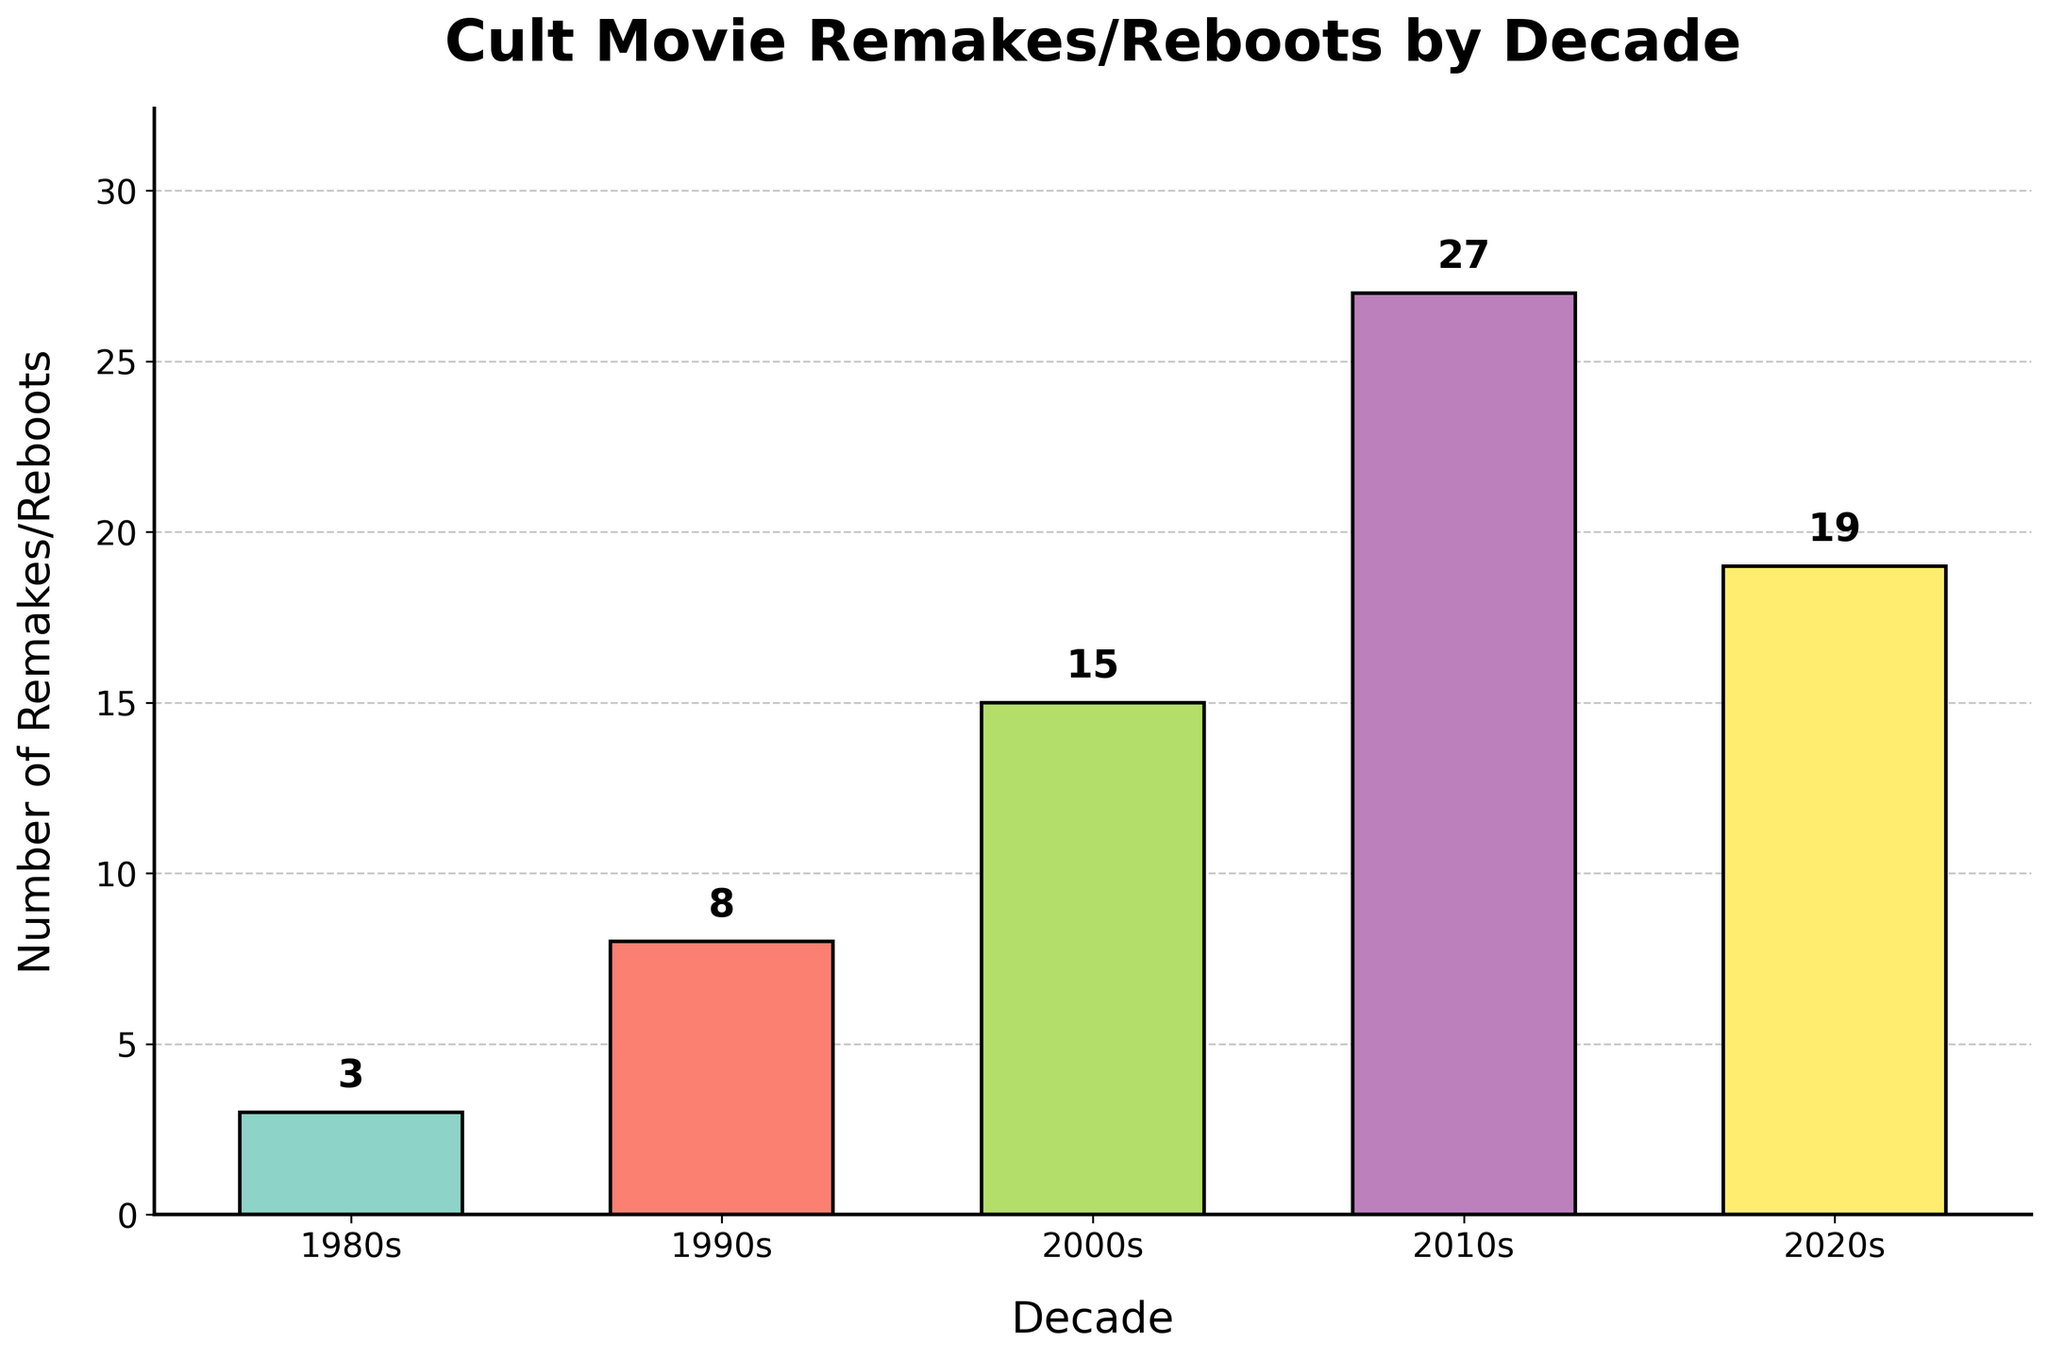What decade had the highest number of remakes/reboots? Look for the tallest bar in the chart. The tallest bar represents the 2010s.
Answer: 2010s By how much did the number of remakes/reboots increase from the 1980s to the 2010s? Subtract the value for the 1980s from the value for the 2010s. The values are 27 for the 2010s and 3 for the 1980s, so: 27 - 3 = 24.
Answer: 24 What is the total number of remakes/reboots over all the decades? Sum the numbers for all the decades: 3 + 8 + 15 + 27 + 19 = 72.
Answer: 72 Which decade had fewer remakes/reboots: the 1990s or the 2020s? Compare the heights of the bars for the 1990s and the 2020s. The 1990s (8) has fewer than the 2020s (19).
Answer: 1990s What is the average number of remakes/reboots per decade? Sum all the numbers (3 + 8 + 15 + 27 + 19 = 72) and divide by the number of decades (5). So, 72/5 = 14.4.
Answer: 14.4 How many more remakes/reboots were there in the 2000s compared to the 1980s? Subtract the number for the 1980s from the number for the 2000s: 15 - 3 = 12.
Answer: 12 Which two decades had the closest number of remakes/reboots? Compare the numbers for all decades to find the smallest difference. The differences are: 8 - 3 = 5 (1980s and 1990s), 15 - 8 = 7 (1990s and 2000s), 27 - 15 = 12 (2000s and 2010s), 27 - 19 = 8 (2010s and 2020s). The closest are the 1980s and 1990s with a difference of 5.
Answer: 1980s and 1990s Rank the decades from highest to lowest in terms of number of remakes/reboots. List the decades in descending order based on the height of the bars: 2010s (27), 2020s (19), 2000s (15), 1990s (8), 1980s (3).
Answer: 2010s, 2020s, 2000s, 1990s, 1980s What percentage of the total remakes/reboots occurred in the 2010s? Divide the number for the 2010s by the total and multiply by 100: (27/72) * 100 ≈ 37.5%.
Answer: 37.5% How does the growth trend of remakes/reboots change from the 2010s to the 2020s? Visual inspection shows the number decreased from the 2010s (27) to the 2020s (19).
Answer: Decreased 